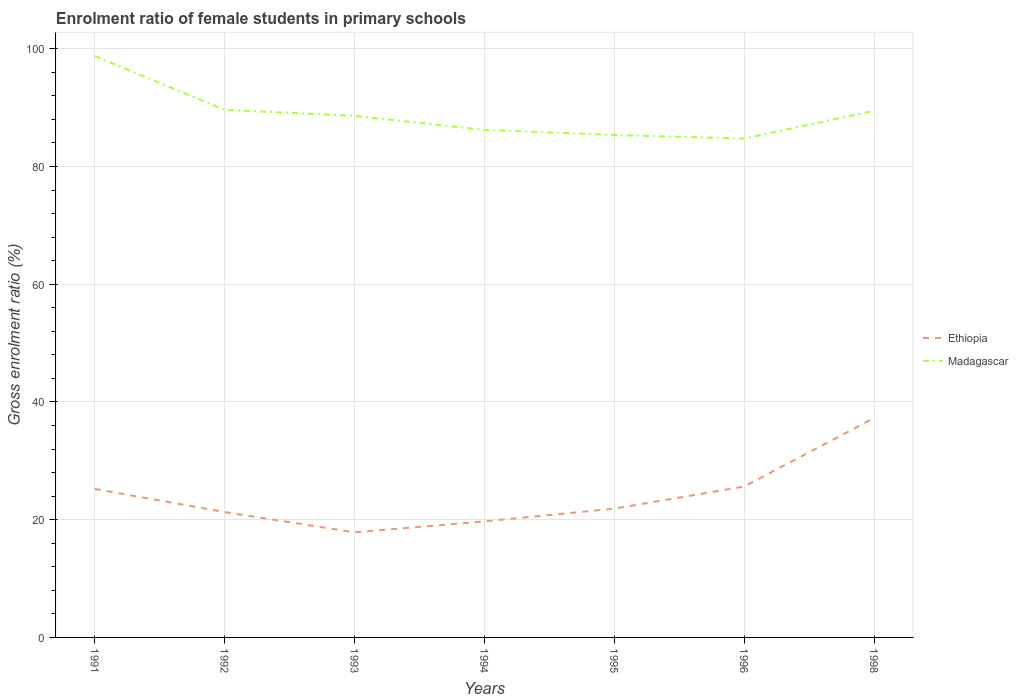How many different coloured lines are there?
Offer a very short reply. 2. Does the line corresponding to Madagascar intersect with the line corresponding to Ethiopia?
Your response must be concise. No. Is the number of lines equal to the number of legend labels?
Provide a succinct answer. Yes. Across all years, what is the maximum enrolment ratio of female students in primary schools in Ethiopia?
Ensure brevity in your answer.  17.85. What is the total enrolment ratio of female students in primary schools in Ethiopia in the graph?
Make the answer very short. -0.41. What is the difference between the highest and the second highest enrolment ratio of female students in primary schools in Ethiopia?
Give a very brief answer. 19.41. What is the difference between the highest and the lowest enrolment ratio of female students in primary schools in Ethiopia?
Your answer should be very brief. 3. How many lines are there?
Give a very brief answer. 2. How many years are there in the graph?
Ensure brevity in your answer.  7. What is the difference between two consecutive major ticks on the Y-axis?
Provide a short and direct response. 20. Where does the legend appear in the graph?
Make the answer very short. Center right. What is the title of the graph?
Your answer should be compact. Enrolment ratio of female students in primary schools. What is the label or title of the Y-axis?
Give a very brief answer. Gross enrolment ratio (%). What is the Gross enrolment ratio (%) of Ethiopia in 1991?
Your response must be concise. 25.22. What is the Gross enrolment ratio (%) in Madagascar in 1991?
Ensure brevity in your answer.  98.75. What is the Gross enrolment ratio (%) of Ethiopia in 1992?
Provide a short and direct response. 21.29. What is the Gross enrolment ratio (%) in Madagascar in 1992?
Give a very brief answer. 89.62. What is the Gross enrolment ratio (%) of Ethiopia in 1993?
Ensure brevity in your answer.  17.85. What is the Gross enrolment ratio (%) of Madagascar in 1993?
Give a very brief answer. 88.6. What is the Gross enrolment ratio (%) in Ethiopia in 1994?
Your response must be concise. 19.71. What is the Gross enrolment ratio (%) of Madagascar in 1994?
Make the answer very short. 86.22. What is the Gross enrolment ratio (%) of Ethiopia in 1995?
Your response must be concise. 21.87. What is the Gross enrolment ratio (%) in Madagascar in 1995?
Offer a very short reply. 85.35. What is the Gross enrolment ratio (%) in Ethiopia in 1996?
Offer a very short reply. 25.63. What is the Gross enrolment ratio (%) in Madagascar in 1996?
Give a very brief answer. 84.74. What is the Gross enrolment ratio (%) of Ethiopia in 1998?
Give a very brief answer. 37.27. What is the Gross enrolment ratio (%) in Madagascar in 1998?
Offer a terse response. 89.46. Across all years, what is the maximum Gross enrolment ratio (%) in Ethiopia?
Your response must be concise. 37.27. Across all years, what is the maximum Gross enrolment ratio (%) of Madagascar?
Ensure brevity in your answer.  98.75. Across all years, what is the minimum Gross enrolment ratio (%) of Ethiopia?
Your answer should be very brief. 17.85. Across all years, what is the minimum Gross enrolment ratio (%) in Madagascar?
Offer a very short reply. 84.74. What is the total Gross enrolment ratio (%) of Ethiopia in the graph?
Offer a terse response. 168.85. What is the total Gross enrolment ratio (%) of Madagascar in the graph?
Keep it short and to the point. 622.74. What is the difference between the Gross enrolment ratio (%) in Ethiopia in 1991 and that in 1992?
Ensure brevity in your answer.  3.93. What is the difference between the Gross enrolment ratio (%) of Madagascar in 1991 and that in 1992?
Your answer should be very brief. 9.13. What is the difference between the Gross enrolment ratio (%) in Ethiopia in 1991 and that in 1993?
Ensure brevity in your answer.  7.37. What is the difference between the Gross enrolment ratio (%) of Madagascar in 1991 and that in 1993?
Keep it short and to the point. 10.15. What is the difference between the Gross enrolment ratio (%) of Ethiopia in 1991 and that in 1994?
Make the answer very short. 5.52. What is the difference between the Gross enrolment ratio (%) in Madagascar in 1991 and that in 1994?
Your response must be concise. 12.54. What is the difference between the Gross enrolment ratio (%) in Ethiopia in 1991 and that in 1995?
Provide a succinct answer. 3.35. What is the difference between the Gross enrolment ratio (%) of Madagascar in 1991 and that in 1995?
Make the answer very short. 13.4. What is the difference between the Gross enrolment ratio (%) in Ethiopia in 1991 and that in 1996?
Ensure brevity in your answer.  -0.41. What is the difference between the Gross enrolment ratio (%) of Madagascar in 1991 and that in 1996?
Your answer should be very brief. 14.02. What is the difference between the Gross enrolment ratio (%) of Ethiopia in 1991 and that in 1998?
Give a very brief answer. -12.04. What is the difference between the Gross enrolment ratio (%) of Madagascar in 1991 and that in 1998?
Your answer should be compact. 9.29. What is the difference between the Gross enrolment ratio (%) in Ethiopia in 1992 and that in 1993?
Your answer should be very brief. 3.44. What is the difference between the Gross enrolment ratio (%) of Madagascar in 1992 and that in 1993?
Provide a succinct answer. 1.02. What is the difference between the Gross enrolment ratio (%) of Ethiopia in 1992 and that in 1994?
Your answer should be compact. 1.58. What is the difference between the Gross enrolment ratio (%) in Madagascar in 1992 and that in 1994?
Ensure brevity in your answer.  3.4. What is the difference between the Gross enrolment ratio (%) in Ethiopia in 1992 and that in 1995?
Your answer should be compact. -0.58. What is the difference between the Gross enrolment ratio (%) in Madagascar in 1992 and that in 1995?
Keep it short and to the point. 4.27. What is the difference between the Gross enrolment ratio (%) of Ethiopia in 1992 and that in 1996?
Keep it short and to the point. -4.34. What is the difference between the Gross enrolment ratio (%) in Madagascar in 1992 and that in 1996?
Provide a short and direct response. 4.88. What is the difference between the Gross enrolment ratio (%) of Ethiopia in 1992 and that in 1998?
Keep it short and to the point. -15.98. What is the difference between the Gross enrolment ratio (%) in Madagascar in 1992 and that in 1998?
Provide a short and direct response. 0.16. What is the difference between the Gross enrolment ratio (%) of Ethiopia in 1993 and that in 1994?
Offer a terse response. -1.85. What is the difference between the Gross enrolment ratio (%) of Madagascar in 1993 and that in 1994?
Your response must be concise. 2.39. What is the difference between the Gross enrolment ratio (%) of Ethiopia in 1993 and that in 1995?
Your answer should be compact. -4.02. What is the difference between the Gross enrolment ratio (%) in Madagascar in 1993 and that in 1995?
Your answer should be very brief. 3.25. What is the difference between the Gross enrolment ratio (%) of Ethiopia in 1993 and that in 1996?
Provide a succinct answer. -7.78. What is the difference between the Gross enrolment ratio (%) in Madagascar in 1993 and that in 1996?
Offer a very short reply. 3.86. What is the difference between the Gross enrolment ratio (%) in Ethiopia in 1993 and that in 1998?
Offer a terse response. -19.41. What is the difference between the Gross enrolment ratio (%) in Madagascar in 1993 and that in 1998?
Ensure brevity in your answer.  -0.86. What is the difference between the Gross enrolment ratio (%) of Ethiopia in 1994 and that in 1995?
Give a very brief answer. -2.17. What is the difference between the Gross enrolment ratio (%) in Madagascar in 1994 and that in 1995?
Your response must be concise. 0.86. What is the difference between the Gross enrolment ratio (%) of Ethiopia in 1994 and that in 1996?
Provide a short and direct response. -5.92. What is the difference between the Gross enrolment ratio (%) in Madagascar in 1994 and that in 1996?
Offer a very short reply. 1.48. What is the difference between the Gross enrolment ratio (%) in Ethiopia in 1994 and that in 1998?
Ensure brevity in your answer.  -17.56. What is the difference between the Gross enrolment ratio (%) in Madagascar in 1994 and that in 1998?
Make the answer very short. -3.25. What is the difference between the Gross enrolment ratio (%) of Ethiopia in 1995 and that in 1996?
Keep it short and to the point. -3.76. What is the difference between the Gross enrolment ratio (%) in Madagascar in 1995 and that in 1996?
Keep it short and to the point. 0.62. What is the difference between the Gross enrolment ratio (%) of Ethiopia in 1995 and that in 1998?
Your answer should be very brief. -15.39. What is the difference between the Gross enrolment ratio (%) of Madagascar in 1995 and that in 1998?
Keep it short and to the point. -4.11. What is the difference between the Gross enrolment ratio (%) of Ethiopia in 1996 and that in 1998?
Keep it short and to the point. -11.63. What is the difference between the Gross enrolment ratio (%) in Madagascar in 1996 and that in 1998?
Your answer should be compact. -4.73. What is the difference between the Gross enrolment ratio (%) in Ethiopia in 1991 and the Gross enrolment ratio (%) in Madagascar in 1992?
Provide a succinct answer. -64.39. What is the difference between the Gross enrolment ratio (%) of Ethiopia in 1991 and the Gross enrolment ratio (%) of Madagascar in 1993?
Offer a terse response. -63.38. What is the difference between the Gross enrolment ratio (%) of Ethiopia in 1991 and the Gross enrolment ratio (%) of Madagascar in 1994?
Make the answer very short. -60.99. What is the difference between the Gross enrolment ratio (%) of Ethiopia in 1991 and the Gross enrolment ratio (%) of Madagascar in 1995?
Make the answer very short. -60.13. What is the difference between the Gross enrolment ratio (%) in Ethiopia in 1991 and the Gross enrolment ratio (%) in Madagascar in 1996?
Your response must be concise. -59.51. What is the difference between the Gross enrolment ratio (%) in Ethiopia in 1991 and the Gross enrolment ratio (%) in Madagascar in 1998?
Ensure brevity in your answer.  -64.24. What is the difference between the Gross enrolment ratio (%) in Ethiopia in 1992 and the Gross enrolment ratio (%) in Madagascar in 1993?
Provide a succinct answer. -67.31. What is the difference between the Gross enrolment ratio (%) of Ethiopia in 1992 and the Gross enrolment ratio (%) of Madagascar in 1994?
Your answer should be compact. -64.93. What is the difference between the Gross enrolment ratio (%) of Ethiopia in 1992 and the Gross enrolment ratio (%) of Madagascar in 1995?
Provide a short and direct response. -64.06. What is the difference between the Gross enrolment ratio (%) in Ethiopia in 1992 and the Gross enrolment ratio (%) in Madagascar in 1996?
Your answer should be very brief. -63.45. What is the difference between the Gross enrolment ratio (%) in Ethiopia in 1992 and the Gross enrolment ratio (%) in Madagascar in 1998?
Give a very brief answer. -68.17. What is the difference between the Gross enrolment ratio (%) of Ethiopia in 1993 and the Gross enrolment ratio (%) of Madagascar in 1994?
Your answer should be compact. -68.36. What is the difference between the Gross enrolment ratio (%) in Ethiopia in 1993 and the Gross enrolment ratio (%) in Madagascar in 1995?
Provide a short and direct response. -67.5. What is the difference between the Gross enrolment ratio (%) of Ethiopia in 1993 and the Gross enrolment ratio (%) of Madagascar in 1996?
Provide a short and direct response. -66.88. What is the difference between the Gross enrolment ratio (%) of Ethiopia in 1993 and the Gross enrolment ratio (%) of Madagascar in 1998?
Your response must be concise. -71.61. What is the difference between the Gross enrolment ratio (%) in Ethiopia in 1994 and the Gross enrolment ratio (%) in Madagascar in 1995?
Give a very brief answer. -65.64. What is the difference between the Gross enrolment ratio (%) in Ethiopia in 1994 and the Gross enrolment ratio (%) in Madagascar in 1996?
Give a very brief answer. -65.03. What is the difference between the Gross enrolment ratio (%) of Ethiopia in 1994 and the Gross enrolment ratio (%) of Madagascar in 1998?
Offer a terse response. -69.76. What is the difference between the Gross enrolment ratio (%) of Ethiopia in 1995 and the Gross enrolment ratio (%) of Madagascar in 1996?
Make the answer very short. -62.86. What is the difference between the Gross enrolment ratio (%) of Ethiopia in 1995 and the Gross enrolment ratio (%) of Madagascar in 1998?
Keep it short and to the point. -67.59. What is the difference between the Gross enrolment ratio (%) in Ethiopia in 1996 and the Gross enrolment ratio (%) in Madagascar in 1998?
Offer a very short reply. -63.83. What is the average Gross enrolment ratio (%) in Ethiopia per year?
Provide a short and direct response. 24.12. What is the average Gross enrolment ratio (%) of Madagascar per year?
Your answer should be compact. 88.96. In the year 1991, what is the difference between the Gross enrolment ratio (%) of Ethiopia and Gross enrolment ratio (%) of Madagascar?
Provide a succinct answer. -73.53. In the year 1992, what is the difference between the Gross enrolment ratio (%) of Ethiopia and Gross enrolment ratio (%) of Madagascar?
Offer a terse response. -68.33. In the year 1993, what is the difference between the Gross enrolment ratio (%) in Ethiopia and Gross enrolment ratio (%) in Madagascar?
Make the answer very short. -70.75. In the year 1994, what is the difference between the Gross enrolment ratio (%) in Ethiopia and Gross enrolment ratio (%) in Madagascar?
Ensure brevity in your answer.  -66.51. In the year 1995, what is the difference between the Gross enrolment ratio (%) in Ethiopia and Gross enrolment ratio (%) in Madagascar?
Offer a very short reply. -63.48. In the year 1996, what is the difference between the Gross enrolment ratio (%) of Ethiopia and Gross enrolment ratio (%) of Madagascar?
Offer a very short reply. -59.11. In the year 1998, what is the difference between the Gross enrolment ratio (%) of Ethiopia and Gross enrolment ratio (%) of Madagascar?
Your answer should be very brief. -52.2. What is the ratio of the Gross enrolment ratio (%) of Ethiopia in 1991 to that in 1992?
Your response must be concise. 1.18. What is the ratio of the Gross enrolment ratio (%) of Madagascar in 1991 to that in 1992?
Your answer should be compact. 1.1. What is the ratio of the Gross enrolment ratio (%) of Ethiopia in 1991 to that in 1993?
Your response must be concise. 1.41. What is the ratio of the Gross enrolment ratio (%) in Madagascar in 1991 to that in 1993?
Offer a very short reply. 1.11. What is the ratio of the Gross enrolment ratio (%) in Ethiopia in 1991 to that in 1994?
Offer a terse response. 1.28. What is the ratio of the Gross enrolment ratio (%) of Madagascar in 1991 to that in 1994?
Ensure brevity in your answer.  1.15. What is the ratio of the Gross enrolment ratio (%) in Ethiopia in 1991 to that in 1995?
Your answer should be very brief. 1.15. What is the ratio of the Gross enrolment ratio (%) of Madagascar in 1991 to that in 1995?
Your response must be concise. 1.16. What is the ratio of the Gross enrolment ratio (%) of Ethiopia in 1991 to that in 1996?
Your answer should be compact. 0.98. What is the ratio of the Gross enrolment ratio (%) of Madagascar in 1991 to that in 1996?
Ensure brevity in your answer.  1.17. What is the ratio of the Gross enrolment ratio (%) in Ethiopia in 1991 to that in 1998?
Offer a very short reply. 0.68. What is the ratio of the Gross enrolment ratio (%) of Madagascar in 1991 to that in 1998?
Your answer should be very brief. 1.1. What is the ratio of the Gross enrolment ratio (%) of Ethiopia in 1992 to that in 1993?
Offer a terse response. 1.19. What is the ratio of the Gross enrolment ratio (%) of Madagascar in 1992 to that in 1993?
Provide a succinct answer. 1.01. What is the ratio of the Gross enrolment ratio (%) in Ethiopia in 1992 to that in 1994?
Your answer should be compact. 1.08. What is the ratio of the Gross enrolment ratio (%) in Madagascar in 1992 to that in 1994?
Make the answer very short. 1.04. What is the ratio of the Gross enrolment ratio (%) of Ethiopia in 1992 to that in 1995?
Your answer should be compact. 0.97. What is the ratio of the Gross enrolment ratio (%) of Ethiopia in 1992 to that in 1996?
Keep it short and to the point. 0.83. What is the ratio of the Gross enrolment ratio (%) of Madagascar in 1992 to that in 1996?
Make the answer very short. 1.06. What is the ratio of the Gross enrolment ratio (%) in Ethiopia in 1992 to that in 1998?
Provide a succinct answer. 0.57. What is the ratio of the Gross enrolment ratio (%) of Madagascar in 1992 to that in 1998?
Ensure brevity in your answer.  1. What is the ratio of the Gross enrolment ratio (%) of Ethiopia in 1993 to that in 1994?
Provide a succinct answer. 0.91. What is the ratio of the Gross enrolment ratio (%) in Madagascar in 1993 to that in 1994?
Give a very brief answer. 1.03. What is the ratio of the Gross enrolment ratio (%) of Ethiopia in 1993 to that in 1995?
Keep it short and to the point. 0.82. What is the ratio of the Gross enrolment ratio (%) in Madagascar in 1993 to that in 1995?
Your answer should be compact. 1.04. What is the ratio of the Gross enrolment ratio (%) of Ethiopia in 1993 to that in 1996?
Your response must be concise. 0.7. What is the ratio of the Gross enrolment ratio (%) in Madagascar in 1993 to that in 1996?
Offer a very short reply. 1.05. What is the ratio of the Gross enrolment ratio (%) in Ethiopia in 1993 to that in 1998?
Your answer should be compact. 0.48. What is the ratio of the Gross enrolment ratio (%) of Ethiopia in 1994 to that in 1995?
Offer a terse response. 0.9. What is the ratio of the Gross enrolment ratio (%) in Madagascar in 1994 to that in 1995?
Provide a succinct answer. 1.01. What is the ratio of the Gross enrolment ratio (%) of Ethiopia in 1994 to that in 1996?
Offer a terse response. 0.77. What is the ratio of the Gross enrolment ratio (%) in Madagascar in 1994 to that in 1996?
Give a very brief answer. 1.02. What is the ratio of the Gross enrolment ratio (%) of Ethiopia in 1994 to that in 1998?
Keep it short and to the point. 0.53. What is the ratio of the Gross enrolment ratio (%) in Madagascar in 1994 to that in 1998?
Provide a short and direct response. 0.96. What is the ratio of the Gross enrolment ratio (%) in Ethiopia in 1995 to that in 1996?
Your response must be concise. 0.85. What is the ratio of the Gross enrolment ratio (%) of Madagascar in 1995 to that in 1996?
Provide a short and direct response. 1.01. What is the ratio of the Gross enrolment ratio (%) in Ethiopia in 1995 to that in 1998?
Your answer should be compact. 0.59. What is the ratio of the Gross enrolment ratio (%) of Madagascar in 1995 to that in 1998?
Your answer should be very brief. 0.95. What is the ratio of the Gross enrolment ratio (%) in Ethiopia in 1996 to that in 1998?
Give a very brief answer. 0.69. What is the ratio of the Gross enrolment ratio (%) in Madagascar in 1996 to that in 1998?
Provide a succinct answer. 0.95. What is the difference between the highest and the second highest Gross enrolment ratio (%) of Ethiopia?
Your answer should be compact. 11.63. What is the difference between the highest and the second highest Gross enrolment ratio (%) in Madagascar?
Provide a short and direct response. 9.13. What is the difference between the highest and the lowest Gross enrolment ratio (%) of Ethiopia?
Ensure brevity in your answer.  19.41. What is the difference between the highest and the lowest Gross enrolment ratio (%) in Madagascar?
Ensure brevity in your answer.  14.02. 